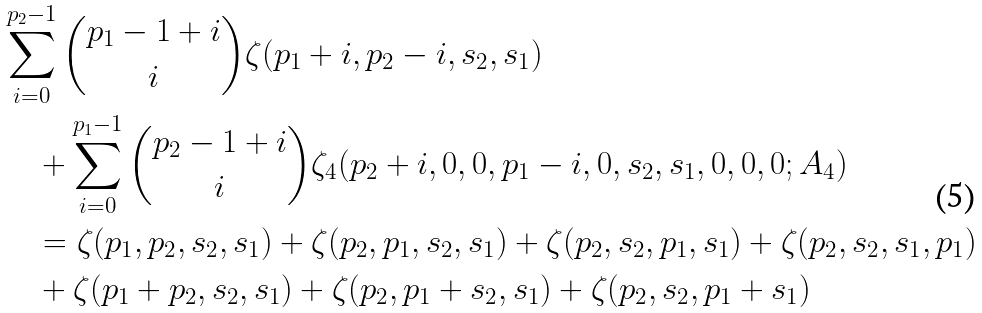Convert formula to latex. <formula><loc_0><loc_0><loc_500><loc_500>& \sum _ { i = 0 } ^ { p _ { 2 } - 1 } \binom { p _ { 1 } - 1 + i } { i } \zeta ( { p _ { 1 } + i } , { p _ { 2 } - i } , { s _ { 2 } } , s _ { 1 } ) \\ & \quad + \sum _ { i = 0 } ^ { p _ { 1 } - 1 } \binom { p _ { 2 } - 1 + i } { i } \zeta _ { 4 } ( { p _ { 2 } + i } , 0 , 0 , p _ { 1 } - i , 0 , s _ { 2 } , s _ { 1 } , 0 , 0 , 0 ; A _ { 4 } ) \\ & \quad = \zeta ( p _ { 1 } , p _ { 2 } , s _ { 2 } , s _ { 1 } ) + \zeta ( p _ { 2 } , p _ { 1 } , s _ { 2 } , s _ { 1 } ) + \zeta ( p _ { 2 } , s _ { 2 } , p _ { 1 } , s _ { 1 } ) + \zeta ( p _ { 2 } , s _ { 2 } , s _ { 1 } , p _ { 1 } ) \\ & \quad + \zeta ( p _ { 1 } + p _ { 2 } , s _ { 2 } , s _ { 1 } ) + \zeta ( p _ { 2 } , p _ { 1 } + s _ { 2 } , s _ { 1 } ) + \zeta ( p _ { 2 } , s _ { 2 } , p _ { 1 } + s _ { 1 } )</formula> 